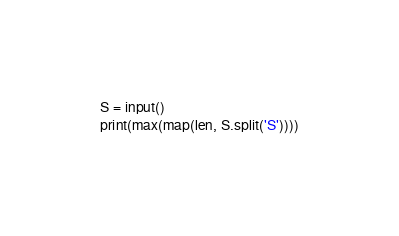<code> <loc_0><loc_0><loc_500><loc_500><_Python_>S = input()
print(max(map(len, S.split('S'))))</code> 